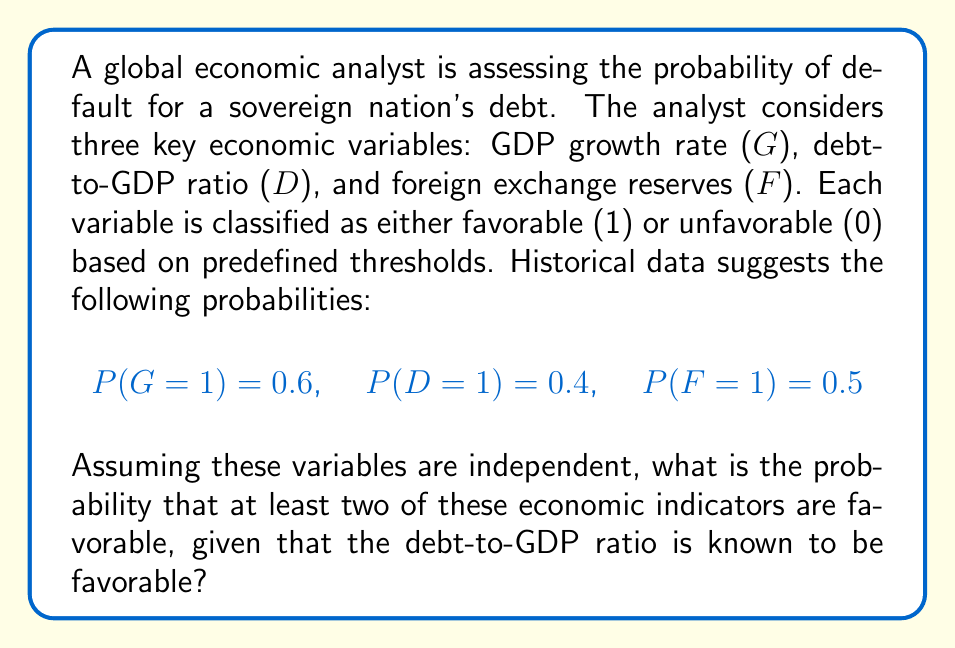Provide a solution to this math problem. Let's approach this step-by-step:

1) First, we need to calculate the probability of at least two indicators being favorable, given that D=1. We can use the conditional probability formula:

   $P(A|B) = \frac{P(A \cap B)}{P(B)}$

   where A is the event of at least two favorable indicators, and B is the event of D=1.

2) To find P(A ∩ B), we need to consider two cases:
   a) All three indicators are favorable
   b) Exactly two indicators are favorable, including D

3) Probability of all three being favorable, given D=1:
   $P(G=1 \cap F=1 | D=1) = P(G=1) \cdot P(F=1) = 0.6 \cdot 0.5 = 0.3$

4) Probability of exactly two being favorable (G=1, F=0 or G=0, F=1), given D=1:
   $P(G=1 \cap F=0 | D=1) + P(G=0 \cap F=1 | D=1)$
   $= P(G=1) \cdot P(F=0) + P(G=0) \cdot P(F=1)$
   $= 0.6 \cdot 0.5 + 0.4 \cdot 0.5 = 0.3 + 0.2 = 0.5$

5) Therefore, $P(A \cap B) = 0.3 + 0.5 = 0.8$

6) We know that $P(B) = P(D=1) = 0.4$

7) Applying the conditional probability formula:

   $P(A|B) = \frac{P(A \cap B)}{P(B)} = \frac{0.8}{0.4} = 2$

Thus, the probability of at least two economic indicators being favorable, given that the debt-to-GDP ratio is favorable, is 2 or 200%.
Answer: 2 (or 200%) 